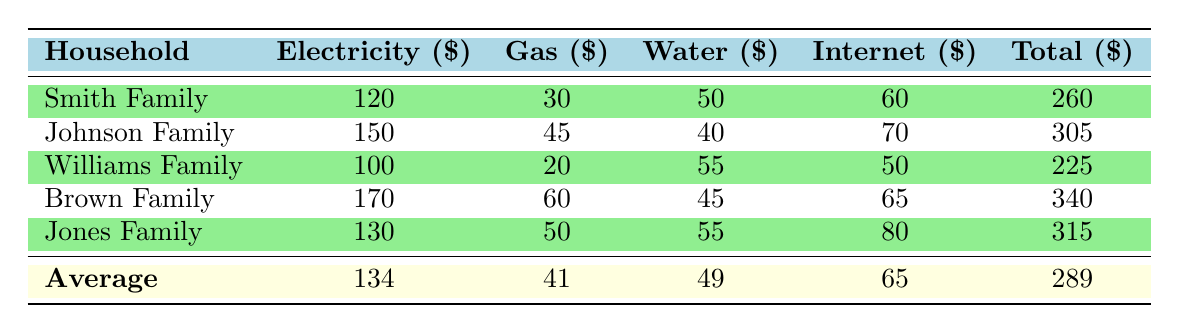What is the total expense for the Brown Family? The table directly lists the total expense for each household. For the Brown Family, the total expense is displayed in the last column as 340.
Answer: 340 Which family has the highest electricity expense? By comparing the electricity expenses listed in the table, we see that the Brown Family has the highest value at 170.
Answer: Brown Family What is the average monthly expense for all families combined? To calculate the average, we first sum the total expenses of all families: (260 + 305 + 225 + 340 + 315) = 1445. There are 5 families, so the average is 1445 / 5 = 289.
Answer: 289 Is the Johnson Family's gas expense greater than the average gas expense? The average gas expense is calculated as follows: (30 + 45 + 20 + 60 + 50) / 5 = 41. The Johnson Family's gas expense is 45, which is greater than 41.
Answer: Yes What is the difference between the total expenses of the Smith Family and the Williams Family? The total expense for the Smith Family is 260, and for the Williams Family, it is 225. The difference is calculated as 260 - 225 = 35.
Answer: 35 Which family spends more on the internet, the Johnson Family or the Jones Family? The internet expenses for the Johnson Family and the Jones Family are 70 and 80, respectively. Comparing these values, 80 is greater than 70.
Answer: Jones Family If the Smith Family reduces their electricity expense by 20 dollars, what would their new total expense be? The Smith Family's current total expense is 260. If they reduce their electricity expense by 20, their new total would be 260 - 20 = 240.
Answer: 240 Which household has the second highest total expense? The households are listed by total expense: Brown Family (340), Jones Family (315), Johnson Family (305), Smith Family (260), and Williams Family (225). The second highest expense is from the Jones Family.
Answer: Jones Family What is the total amount spent on water by all families? The table lists the water expenses for each family as follows: 50 + 40 + 55 + 45 + 55 = 245. Thus, the total spent on water by all families is 245.
Answer: 245 